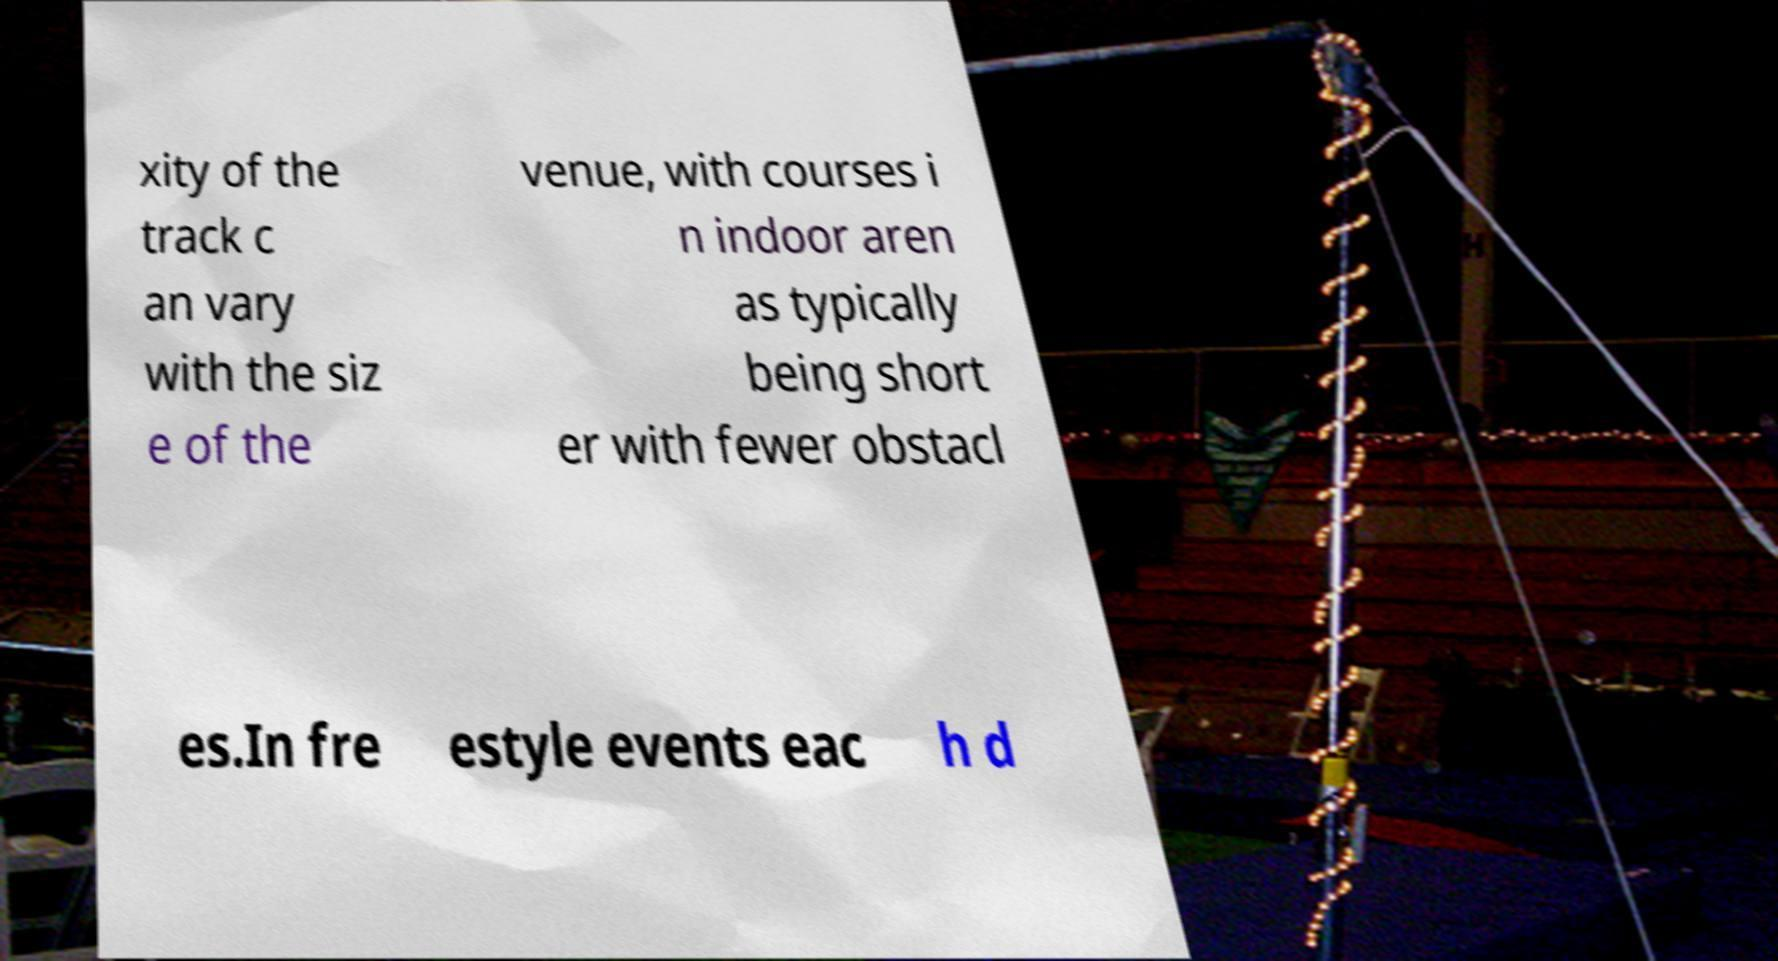For documentation purposes, I need the text within this image transcribed. Could you provide that? xity of the track c an vary with the siz e of the venue, with courses i n indoor aren as typically being short er with fewer obstacl es.In fre estyle events eac h d 